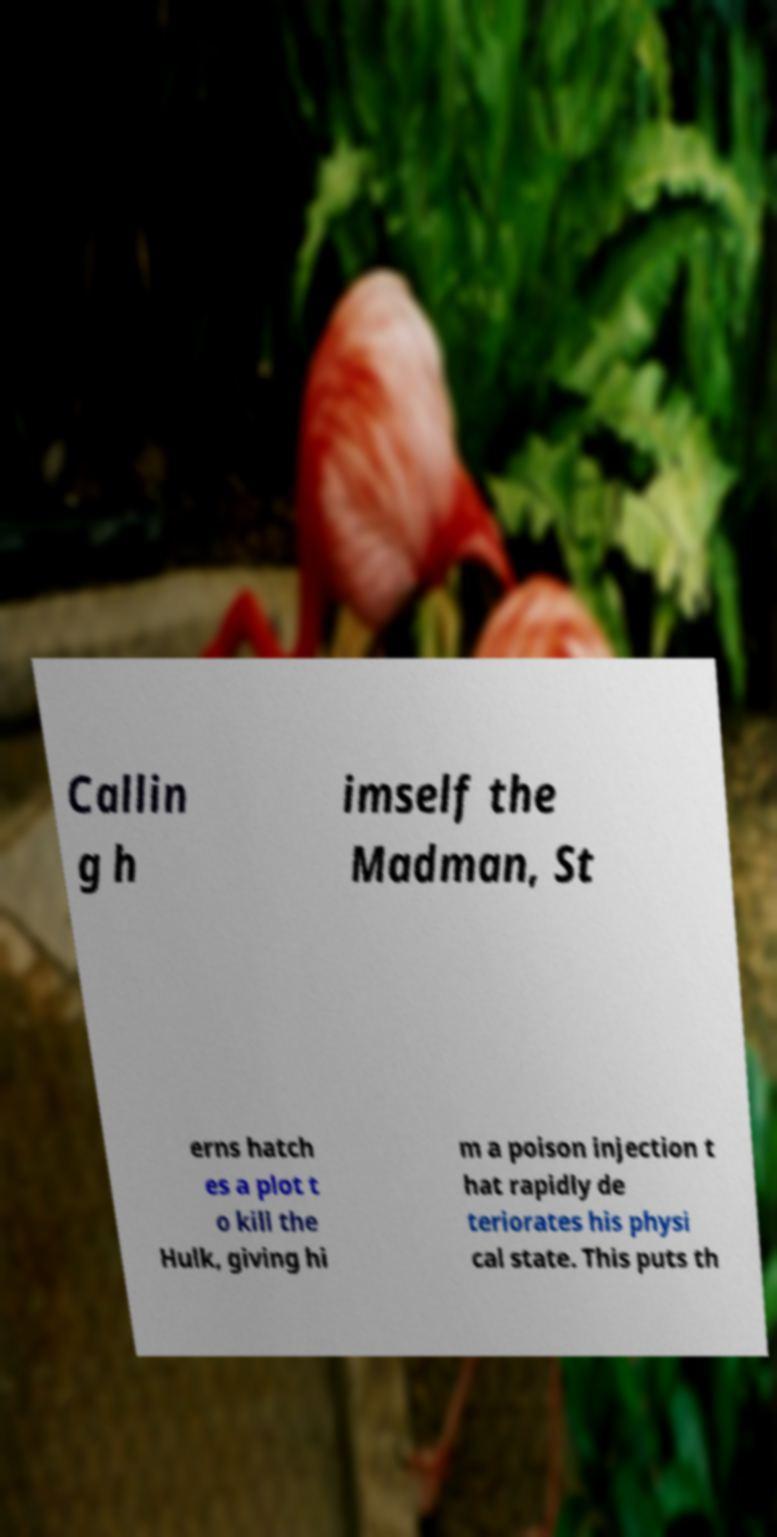Can you read and provide the text displayed in the image?This photo seems to have some interesting text. Can you extract and type it out for me? Callin g h imself the Madman, St erns hatch es a plot t o kill the Hulk, giving hi m a poison injection t hat rapidly de teriorates his physi cal state. This puts th 